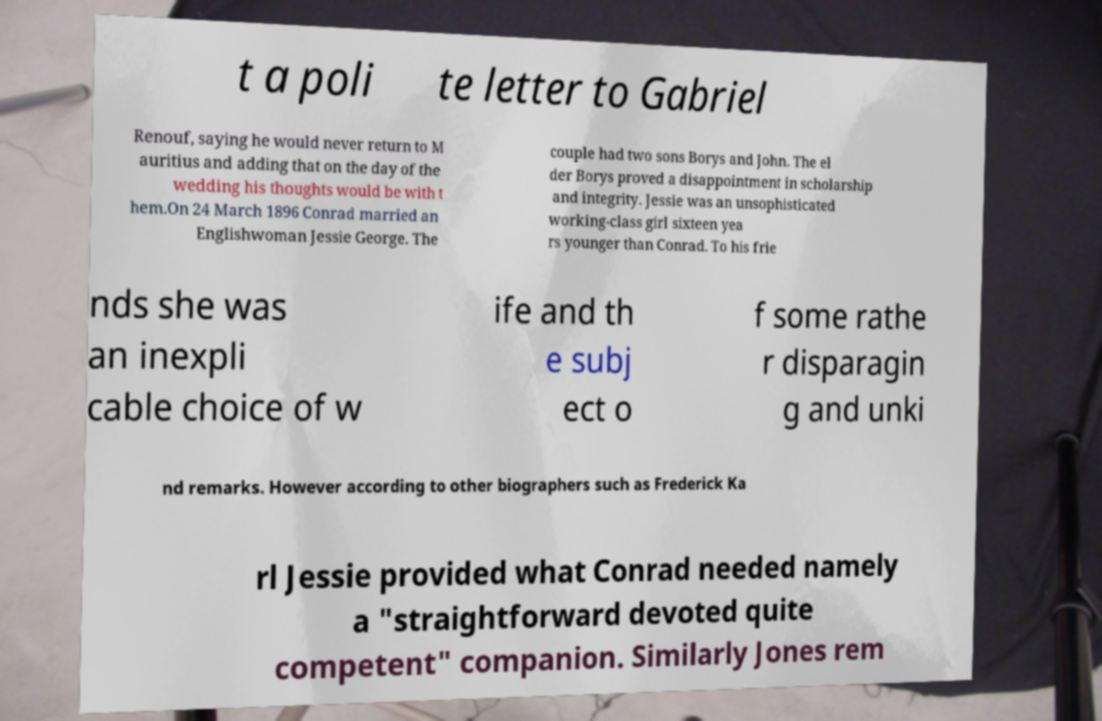What messages or text are displayed in this image? I need them in a readable, typed format. t a poli te letter to Gabriel Renouf, saying he would never return to M auritius and adding that on the day of the wedding his thoughts would be with t hem.On 24 March 1896 Conrad married an Englishwoman Jessie George. The couple had two sons Borys and John. The el der Borys proved a disappointment in scholarship and integrity. Jessie was an unsophisticated working-class girl sixteen yea rs younger than Conrad. To his frie nds she was an inexpli cable choice of w ife and th e subj ect o f some rathe r disparagin g and unki nd remarks. However according to other biographers such as Frederick Ka rl Jessie provided what Conrad needed namely a "straightforward devoted quite competent" companion. Similarly Jones rem 